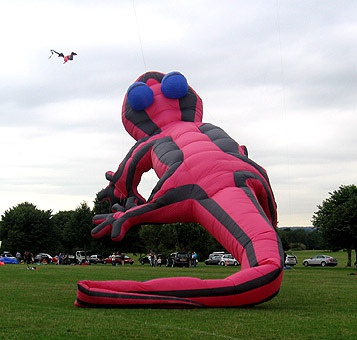Describe the objects in this image and their specific colors. I can see kite in white, black, maroon, and brown tones, car in white, black, gray, darkgray, and purple tones, truck in white, black, gray, darkgray, and maroon tones, car in white, black, maroon, gray, and darkgreen tones, and car in white, black, gray, and darkblue tones in this image. 